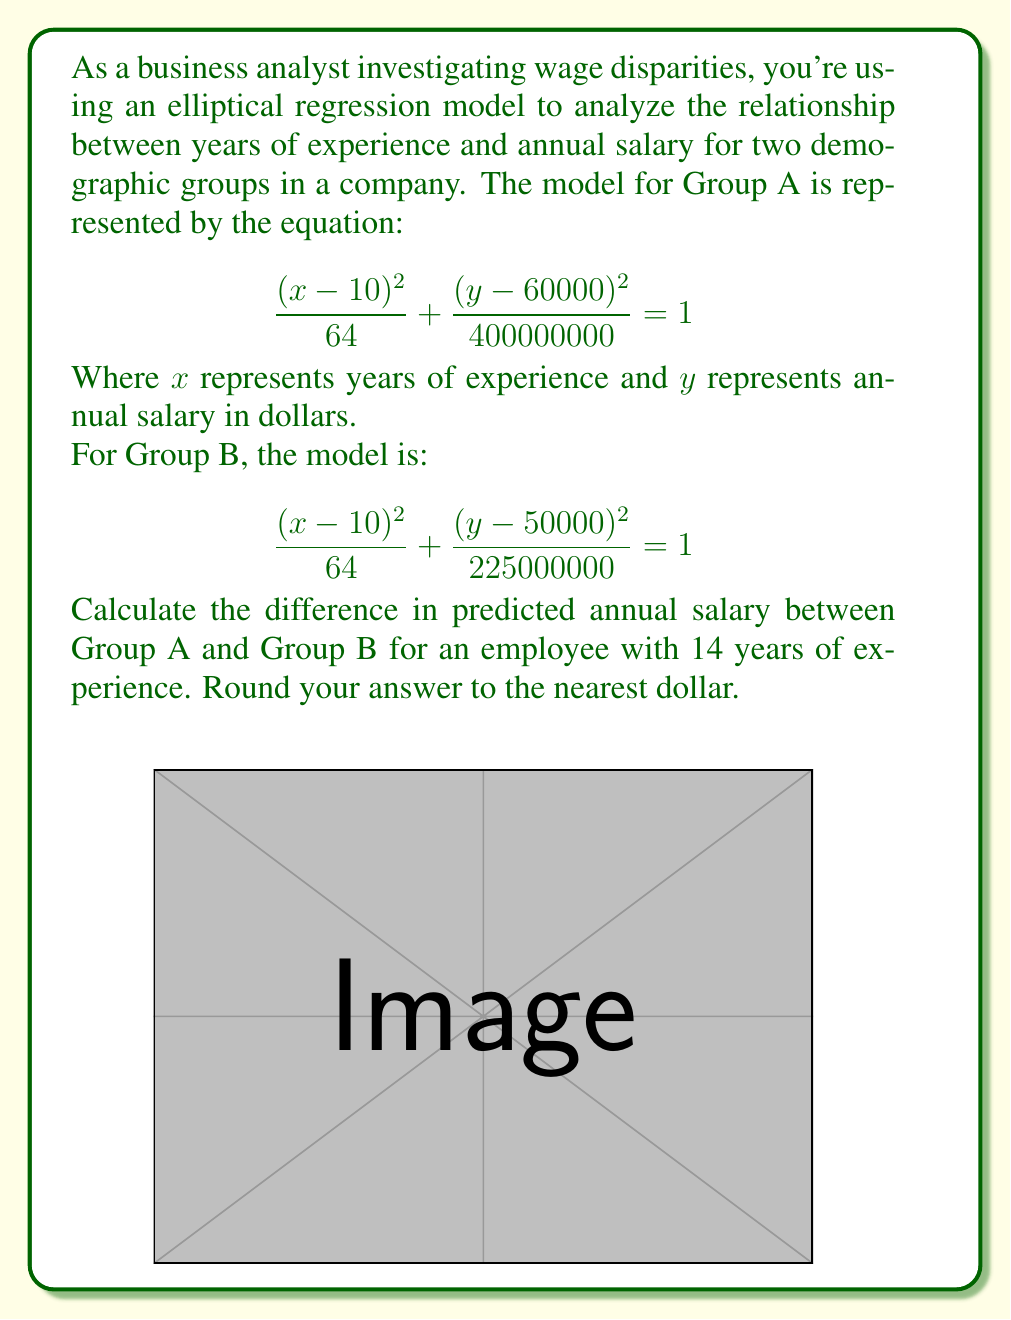Could you help me with this problem? To solve this problem, we'll follow these steps:

1) For each group, we need to find the y-coordinate (salary) when x = 14 (years of experience).

2) For Group A:
   $$\frac{(x-10)^2}{64} + \frac{(y-60000)^2}{400000000} = 1$$
   
   Substituting x = 14:
   $$\frac{(14-10)^2}{64} + \frac{(y-60000)^2}{400000000} = 1$$
   $$\frac{16}{64} + \frac{(y-60000)^2}{400000000} = 1$$
   $$\frac{1}{4} + \frac{(y-60000)^2}{400000000} = 1$$
   $$\frac{(y-60000)^2}{400000000} = \frac{3}{4}$$
   $$(y-60000)^2 = 300000000$$
   $$y-60000 = \pm\sqrt{300000000}$$
   $$y = 60000 \pm 17320.5$$

   We take the positive solution as salaries are typically positive:
   $$y_A = 77320.5$$

3) For Group B:
   $$\frac{(x-10)^2}{64} + \frac{(y-50000)^2}{225000000} = 1$$
   
   Following the same process with x = 14:
   $$\frac{1}{4} + \frac{(y-50000)^2}{225000000} = 1$$
   $$\frac{(y-50000)^2}{225000000} = \frac{3}{4}$$
   $$(y-50000)^2 = 168750000$$
   $$y-50000 = \pm\sqrt{168750000}$$
   $$y = 50000 \pm 12990.38$$

   Taking the positive solution:
   $$y_B = 62990.38$$

4) The difference in predicted salary is:
   $$77320.5 - 62990.38 = 14330.12$$

5) Rounding to the nearest dollar:
   $$14330$$
Answer: $14,330 